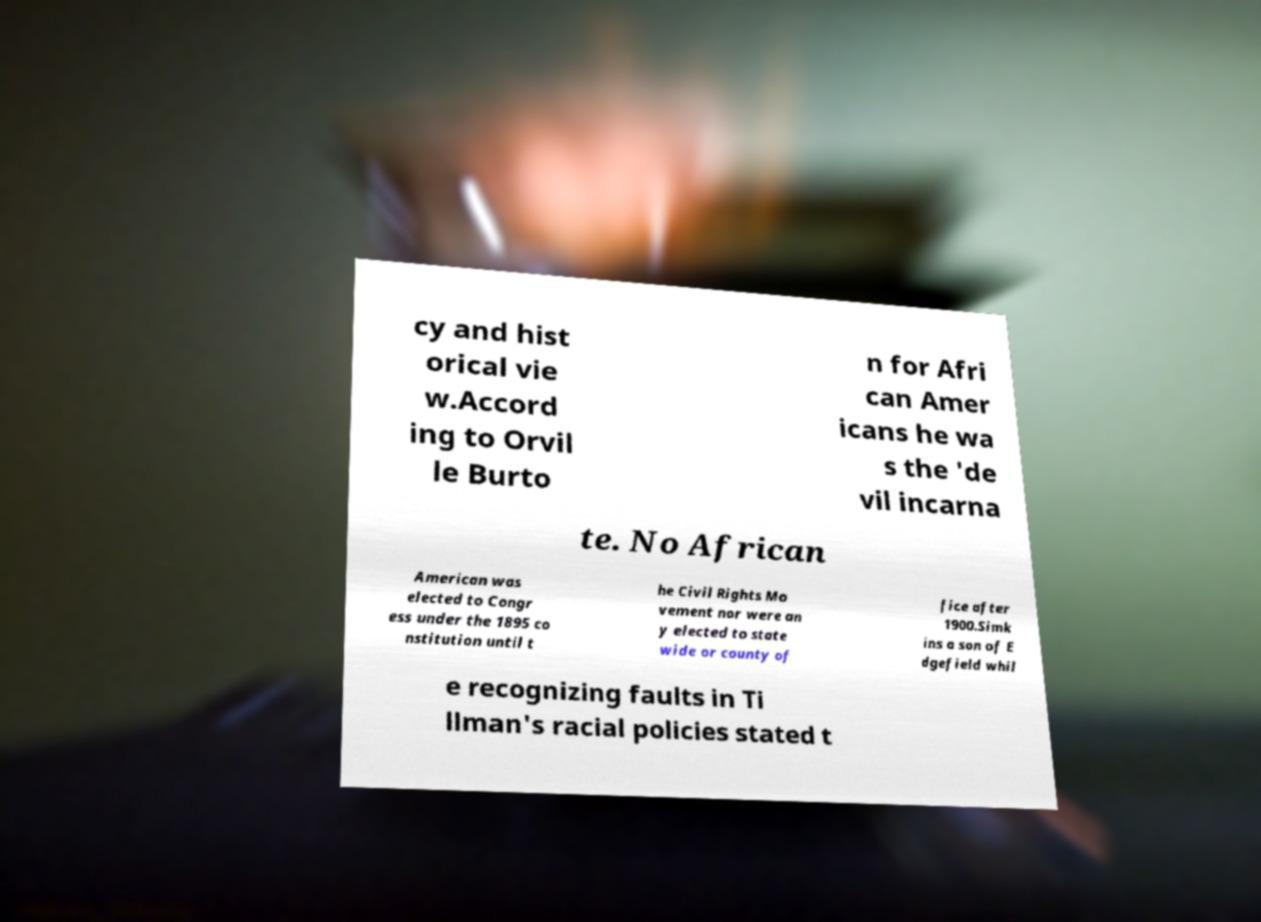Can you read and provide the text displayed in the image?This photo seems to have some interesting text. Can you extract and type it out for me? cy and hist orical vie w.Accord ing to Orvil le Burto n for Afri can Amer icans he wa s the 'de vil incarna te. No African American was elected to Congr ess under the 1895 co nstitution until t he Civil Rights Mo vement nor were an y elected to state wide or county of fice after 1900.Simk ins a son of E dgefield whil e recognizing faults in Ti llman's racial policies stated t 